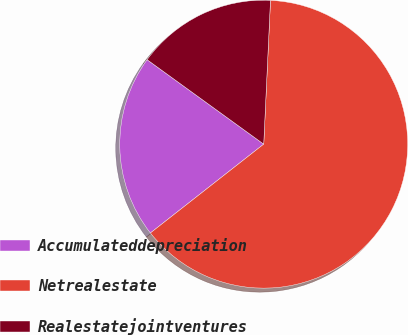<chart> <loc_0><loc_0><loc_500><loc_500><pie_chart><fcel>Accumulateddepreciation<fcel>Netrealestate<fcel>Realestatejointventures<nl><fcel>20.56%<fcel>63.67%<fcel>15.77%<nl></chart> 